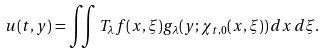<formula> <loc_0><loc_0><loc_500><loc_500>u ( t , y ) = \iint T _ { \lambda } f ( x , \xi ) g _ { \lambda } ( y ; \chi _ { t , 0 } ( x , \xi ) ) \, d x \, d \xi .</formula> 